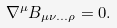Convert formula to latex. <formula><loc_0><loc_0><loc_500><loc_500>\nabla ^ { \mu } B _ { \mu \nu \dots \rho } = 0 .</formula> 